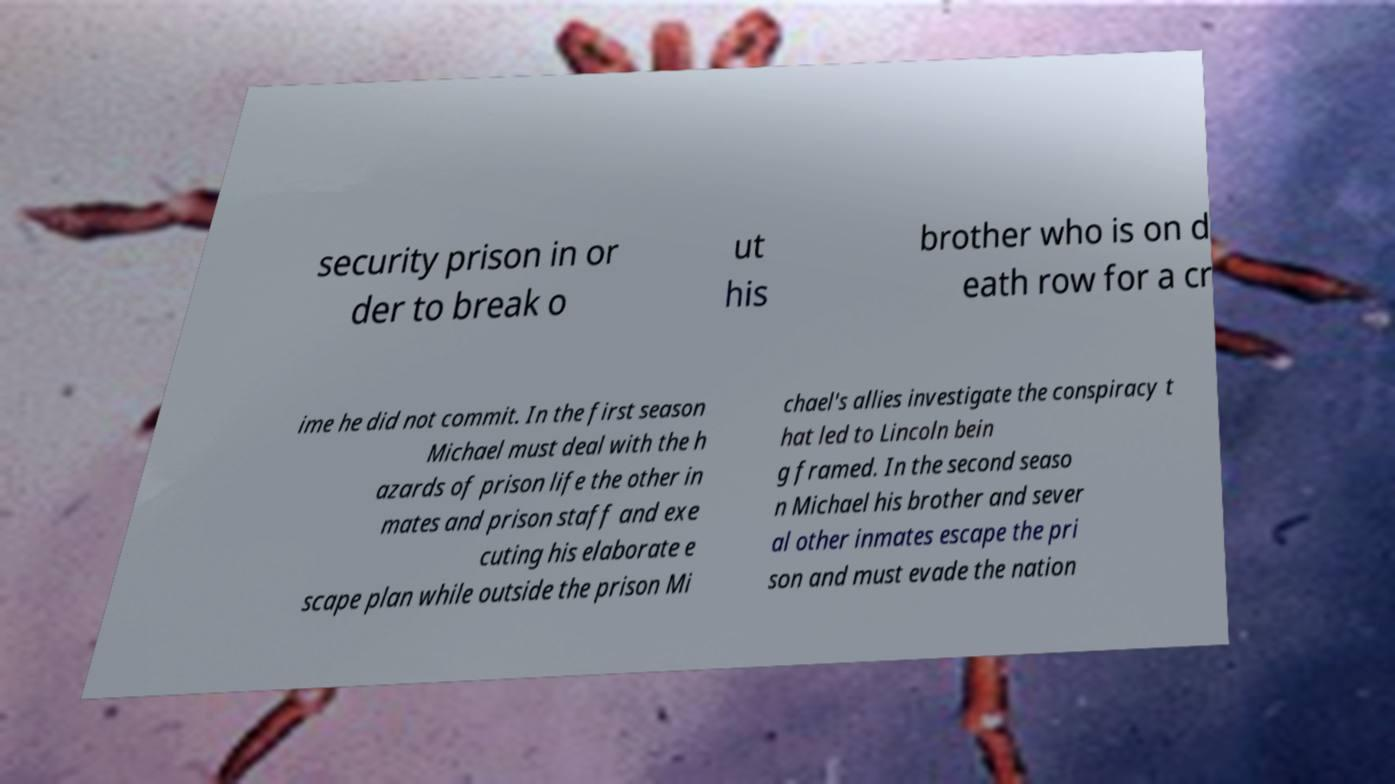Could you assist in decoding the text presented in this image and type it out clearly? security prison in or der to break o ut his brother who is on d eath row for a cr ime he did not commit. In the first season Michael must deal with the h azards of prison life the other in mates and prison staff and exe cuting his elaborate e scape plan while outside the prison Mi chael's allies investigate the conspiracy t hat led to Lincoln bein g framed. In the second seaso n Michael his brother and sever al other inmates escape the pri son and must evade the nation 